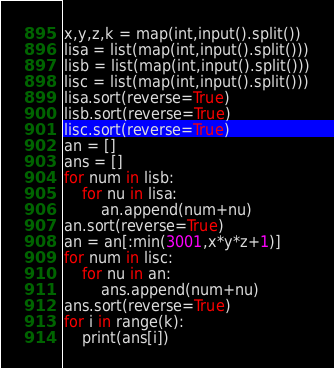Convert code to text. <code><loc_0><loc_0><loc_500><loc_500><_Python_>x,y,z,k = map(int,input().split())
lisa = list(map(int,input().split()))
lisb = list(map(int,input().split()))
lisc = list(map(int,input().split()))
lisa.sort(reverse=True)
lisb.sort(reverse=True)
lisc.sort(reverse=True)
an = []
ans = []
for num in lisb:
    for nu in lisa:
        an.append(num+nu)
an.sort(reverse=True)
an = an[:min(3001,x*y*z+1)]
for num in lisc:
    for nu in an:
        ans.append(num+nu)
ans.sort(reverse=True)
for i in range(k):
    print(ans[i])</code> 